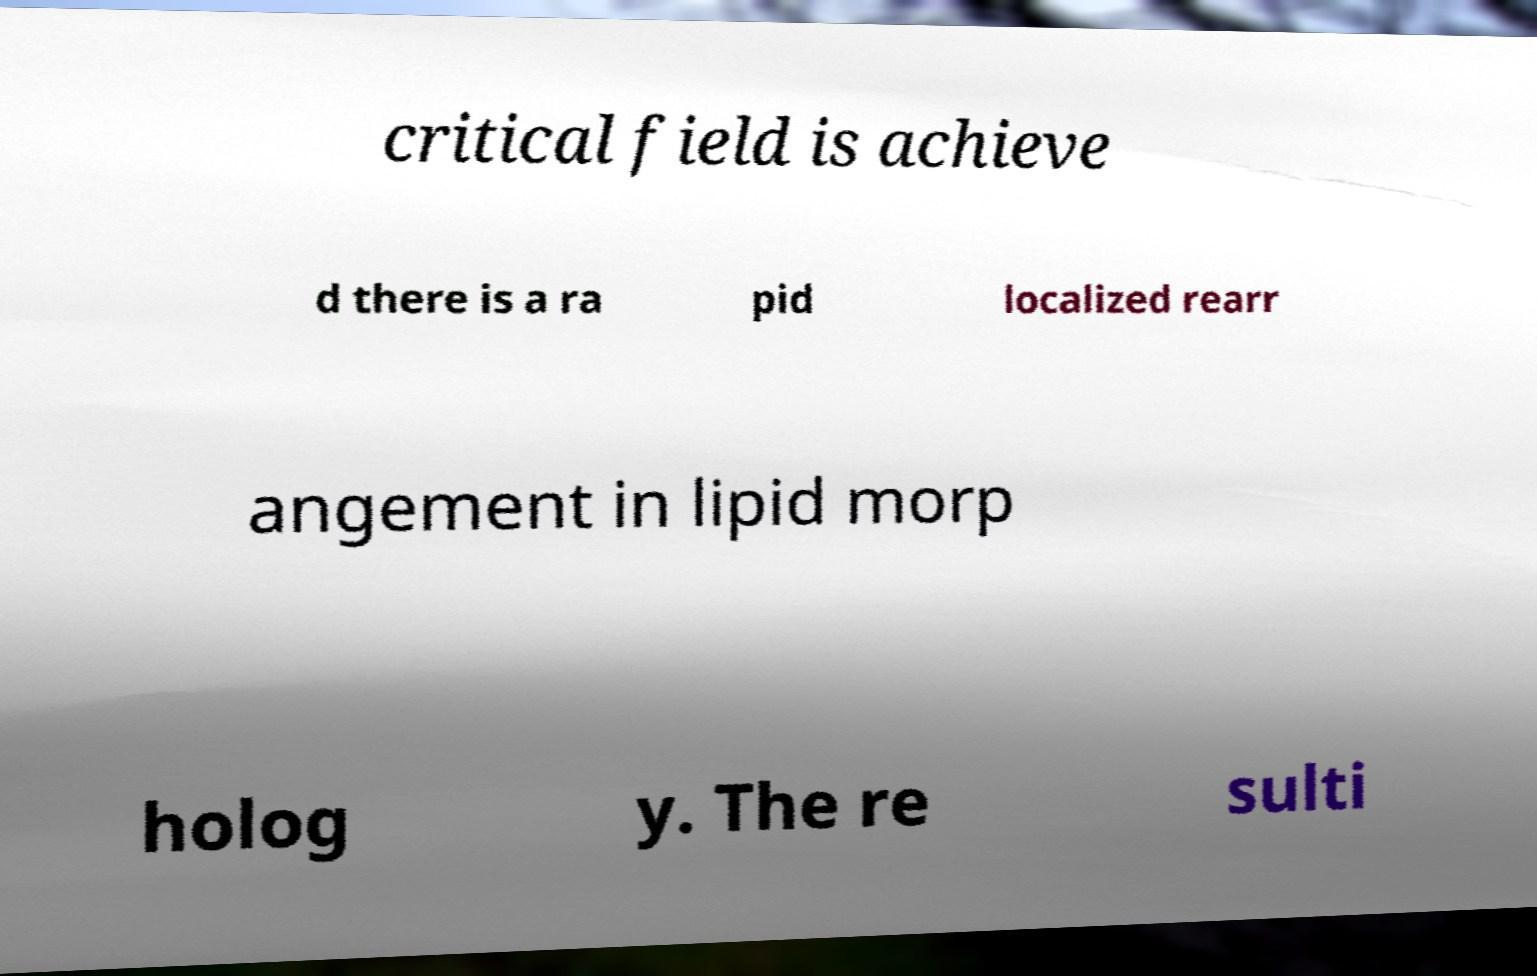There's text embedded in this image that I need extracted. Can you transcribe it verbatim? critical field is achieve d there is a ra pid localized rearr angement in lipid morp holog y. The re sulti 